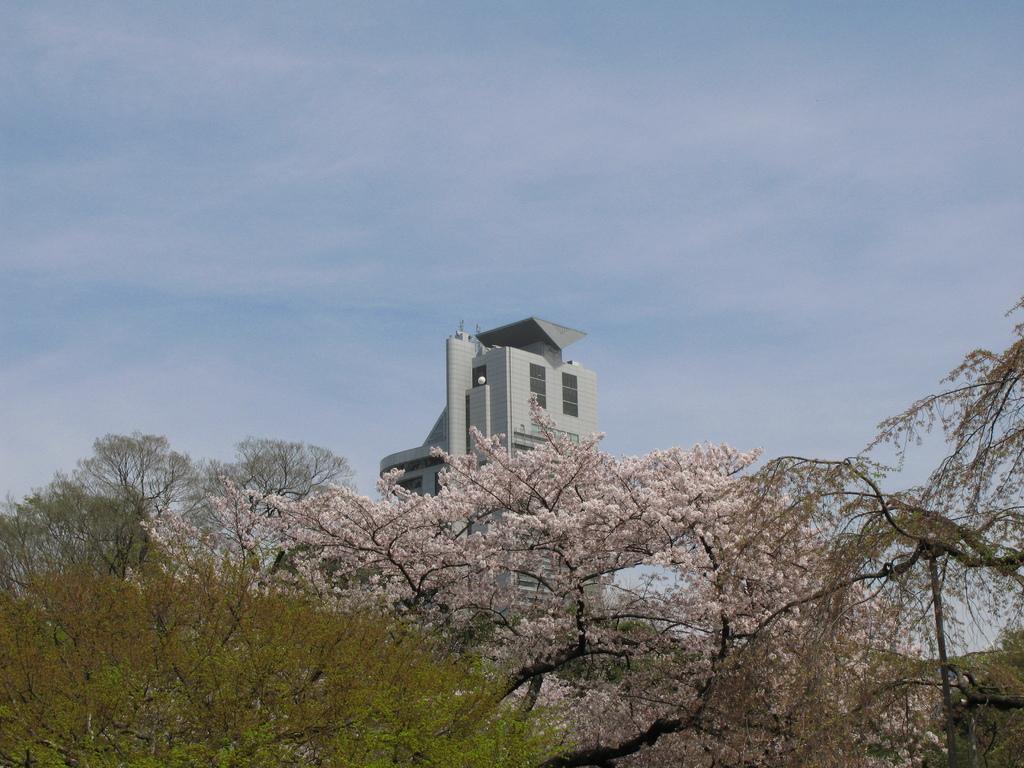Could you give a brief overview of what you see in this image? This picture might be taken from outside of the city. In this image, in the middle, we can see a building, trees with some flowers. In the background, we can also see some trees, at the top, we can see a sky. 